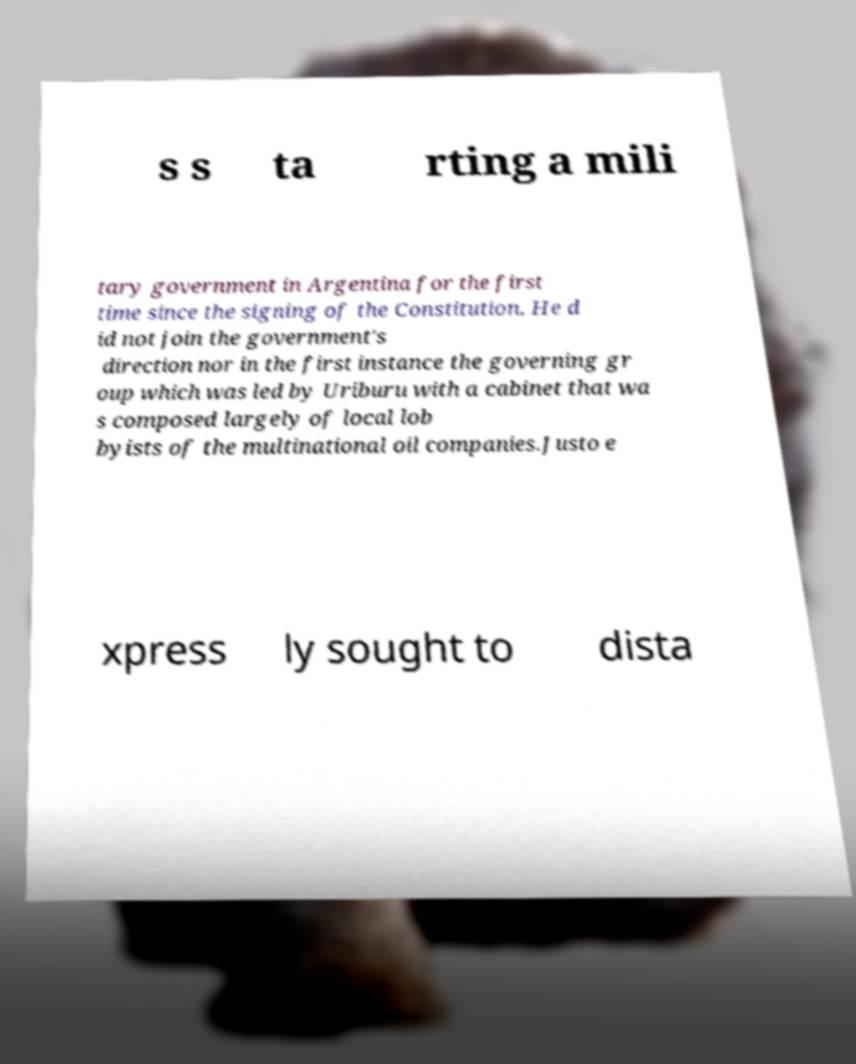I need the written content from this picture converted into text. Can you do that? s s ta rting a mili tary government in Argentina for the first time since the signing of the Constitution. He d id not join the government's direction nor in the first instance the governing gr oup which was led by Uriburu with a cabinet that wa s composed largely of local lob byists of the multinational oil companies.Justo e xpress ly sought to dista 